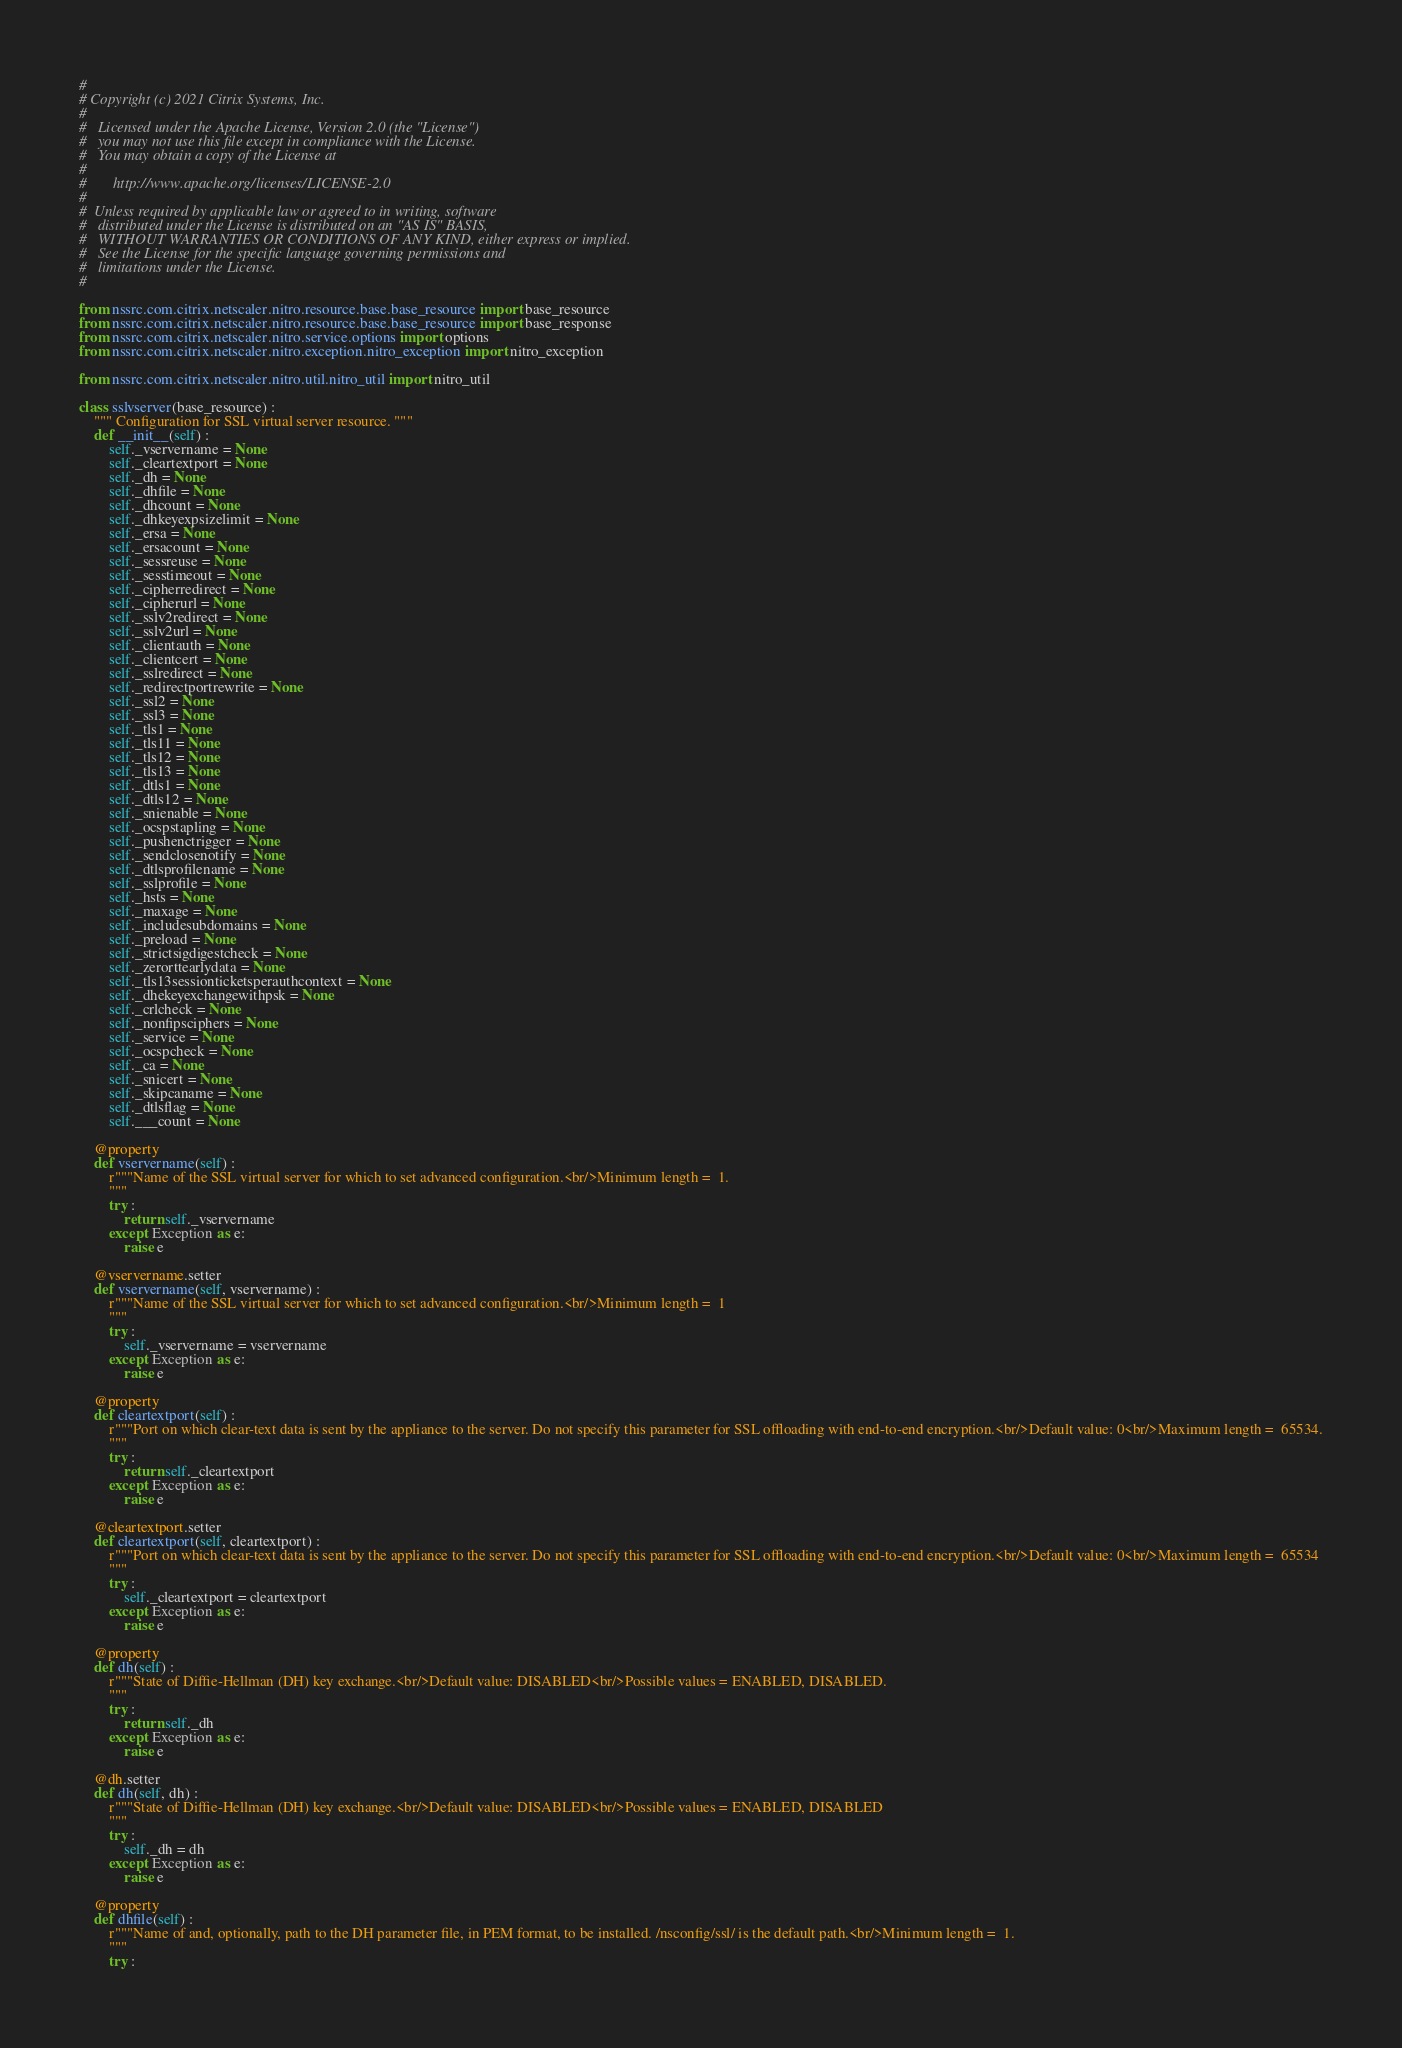Convert code to text. <code><loc_0><loc_0><loc_500><loc_500><_Python_>#
# Copyright (c) 2021 Citrix Systems, Inc.
#
#   Licensed under the Apache License, Version 2.0 (the "License")
#   you may not use this file except in compliance with the License.
#   You may obtain a copy of the License at
#
#       http://www.apache.org/licenses/LICENSE-2.0
#
#  Unless required by applicable law or agreed to in writing, software
#   distributed under the License is distributed on an "AS IS" BASIS,
#   WITHOUT WARRANTIES OR CONDITIONS OF ANY KIND, either express or implied.
#   See the License for the specific language governing permissions and
#   limitations under the License.
#

from nssrc.com.citrix.netscaler.nitro.resource.base.base_resource import base_resource
from nssrc.com.citrix.netscaler.nitro.resource.base.base_resource import base_response
from nssrc.com.citrix.netscaler.nitro.service.options import options
from nssrc.com.citrix.netscaler.nitro.exception.nitro_exception import nitro_exception

from nssrc.com.citrix.netscaler.nitro.util.nitro_util import nitro_util

class sslvserver(base_resource) :
	""" Configuration for SSL virtual server resource. """
	def __init__(self) :
		self._vservername = None
		self._cleartextport = None
		self._dh = None
		self._dhfile = None
		self._dhcount = None
		self._dhkeyexpsizelimit = None
		self._ersa = None
		self._ersacount = None
		self._sessreuse = None
		self._sesstimeout = None
		self._cipherredirect = None
		self._cipherurl = None
		self._sslv2redirect = None
		self._sslv2url = None
		self._clientauth = None
		self._clientcert = None
		self._sslredirect = None
		self._redirectportrewrite = None
		self._ssl2 = None
		self._ssl3 = None
		self._tls1 = None
		self._tls11 = None
		self._tls12 = None
		self._tls13 = None
		self._dtls1 = None
		self._dtls12 = None
		self._snienable = None
		self._ocspstapling = None
		self._pushenctrigger = None
		self._sendclosenotify = None
		self._dtlsprofilename = None
		self._sslprofile = None
		self._hsts = None
		self._maxage = None
		self._includesubdomains = None
		self._preload = None
		self._strictsigdigestcheck = None
		self._zerorttearlydata = None
		self._tls13sessionticketsperauthcontext = None
		self._dhekeyexchangewithpsk = None
		self._crlcheck = None
		self._nonfipsciphers = None
		self._service = None
		self._ocspcheck = None
		self._ca = None
		self._snicert = None
		self._skipcaname = None
		self._dtlsflag = None
		self.___count = None

	@property
	def vservername(self) :
		r"""Name of the SSL virtual server for which to set advanced configuration.<br/>Minimum length =  1.
		"""
		try :
			return self._vservername
		except Exception as e:
			raise e

	@vservername.setter
	def vservername(self, vservername) :
		r"""Name of the SSL virtual server for which to set advanced configuration.<br/>Minimum length =  1
		"""
		try :
			self._vservername = vservername
		except Exception as e:
			raise e

	@property
	def cleartextport(self) :
		r"""Port on which clear-text data is sent by the appliance to the server. Do not specify this parameter for SSL offloading with end-to-end encryption.<br/>Default value: 0<br/>Maximum length =  65534.
		"""
		try :
			return self._cleartextport
		except Exception as e:
			raise e

	@cleartextport.setter
	def cleartextport(self, cleartextport) :
		r"""Port on which clear-text data is sent by the appliance to the server. Do not specify this parameter for SSL offloading with end-to-end encryption.<br/>Default value: 0<br/>Maximum length =  65534
		"""
		try :
			self._cleartextport = cleartextport
		except Exception as e:
			raise e

	@property
	def dh(self) :
		r"""State of Diffie-Hellman (DH) key exchange.<br/>Default value: DISABLED<br/>Possible values = ENABLED, DISABLED.
		"""
		try :
			return self._dh
		except Exception as e:
			raise e

	@dh.setter
	def dh(self, dh) :
		r"""State of Diffie-Hellman (DH) key exchange.<br/>Default value: DISABLED<br/>Possible values = ENABLED, DISABLED
		"""
		try :
			self._dh = dh
		except Exception as e:
			raise e

	@property
	def dhfile(self) :
		r"""Name of and, optionally, path to the DH parameter file, in PEM format, to be installed. /nsconfig/ssl/ is the default path.<br/>Minimum length =  1.
		"""
		try :</code> 